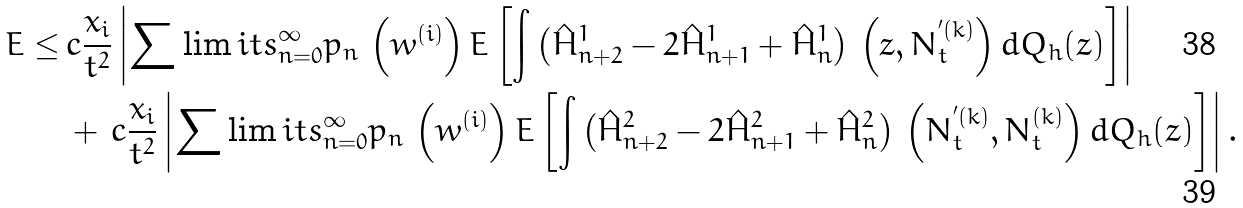<formula> <loc_0><loc_0><loc_500><loc_500>E \leq & \, c \frac { x _ { i } } { t ^ { 2 } } \left | \sum \lim i t s _ { n = 0 } ^ { \infty } p _ { n } \, \left ( w ^ { ( i ) } \right ) E \left [ \int \left ( \hat { H } _ { n + 2 } ^ { 1 } - 2 \hat { H } _ { n + 1 } ^ { 1 } + \hat { H } _ { n } ^ { 1 } \right ) \, \left ( z , N _ { t } ^ { ^ { \prime } ( k ) } \right ) d Q _ { h } ( z ) \right ] \right | \\ & \, + \, c \frac { x _ { i } } { t ^ { 2 } } \left | \sum \lim i t s _ { n = 0 } ^ { \infty } p _ { n } \, \left ( w ^ { ( i ) } \right ) E \left [ \int \left ( \hat { H } _ { n + 2 } ^ { 2 } - 2 \hat { H } _ { n + 1 } ^ { 2 } + \hat { H } _ { n } ^ { 2 } \right ) \, \left ( N _ { t } ^ { ^ { \prime } ( k ) } , N _ { t } ^ { ( k ) } \right ) d Q _ { h } ( z ) \right ] \right | .</formula> 